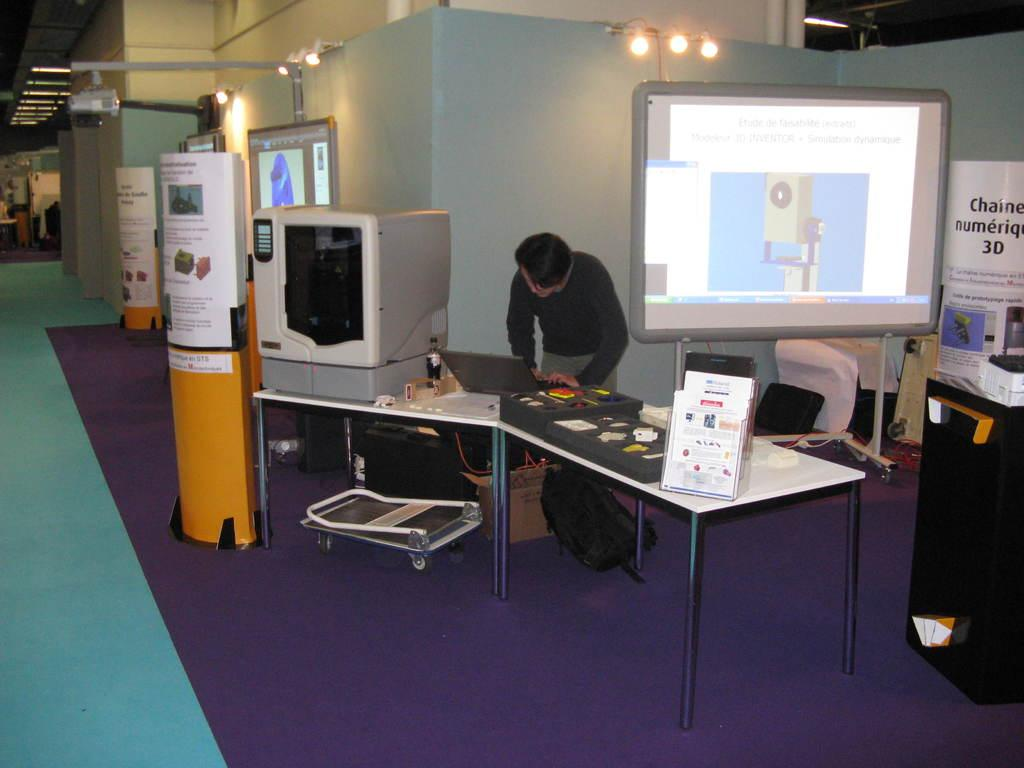What is one of the structures visible in the image? There is a wall in the image. Who or what can be seen standing in the image? There is a man standing in the image. What type of object is present in the image that displays information or visuals? There is a screen in the image. What type of signage is present in the image? There is a banner in the image. What type of furniture is present in the image? There is a table in the image. How many thumbs can be seen on the man's hands in the image? The image does not show the man's hands or thumbs, so it is not possible to determine the number of thumbs present. What type of tray is being used by the man in the image? There is no tray visible in the image. 